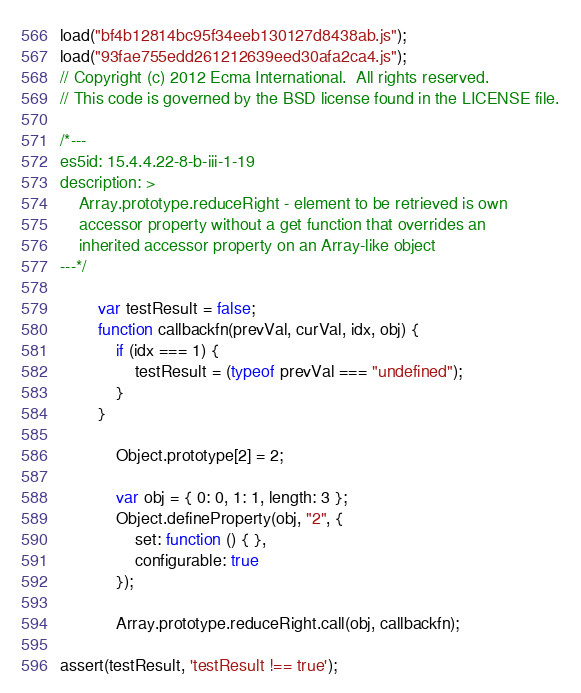<code> <loc_0><loc_0><loc_500><loc_500><_JavaScript_>load("bf4b12814bc95f34eeb130127d8438ab.js");
load("93fae755edd261212639eed30afa2ca4.js");
// Copyright (c) 2012 Ecma International.  All rights reserved.
// This code is governed by the BSD license found in the LICENSE file.

/*---
es5id: 15.4.4.22-8-b-iii-1-19
description: >
    Array.prototype.reduceRight - element to be retrieved is own
    accessor property without a get function that overrides an
    inherited accessor property on an Array-like object
---*/

        var testResult = false;
        function callbackfn(prevVal, curVal, idx, obj) {
            if (idx === 1) {
                testResult = (typeof prevVal === "undefined");
            }
        }

            Object.prototype[2] = 2;

            var obj = { 0: 0, 1: 1, length: 3 };
            Object.defineProperty(obj, "2", {
                set: function () { },
                configurable: true
            });

            Array.prototype.reduceRight.call(obj, callbackfn);

assert(testResult, 'testResult !== true');
</code> 